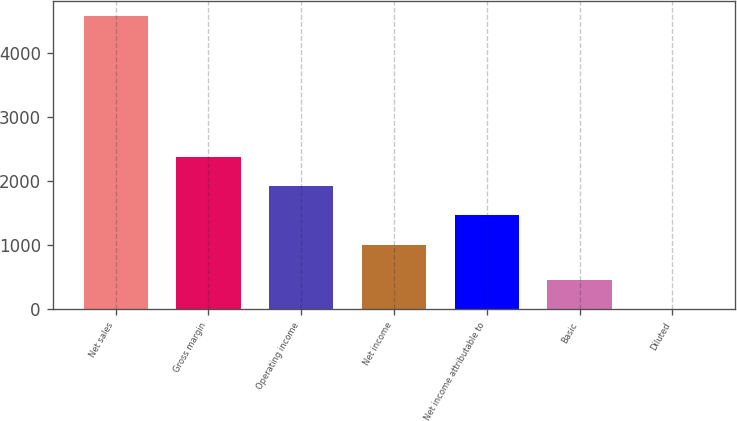<chart> <loc_0><loc_0><loc_500><loc_500><bar_chart><fcel>Net sales<fcel>Gross margin<fcel>Operating income<fcel>Net income<fcel>Net income attributable to<fcel>Basic<fcel>Diluted<nl><fcel>4573<fcel>2373.66<fcel>1916.44<fcel>1002<fcel>1459.22<fcel>458.06<fcel>0.84<nl></chart> 